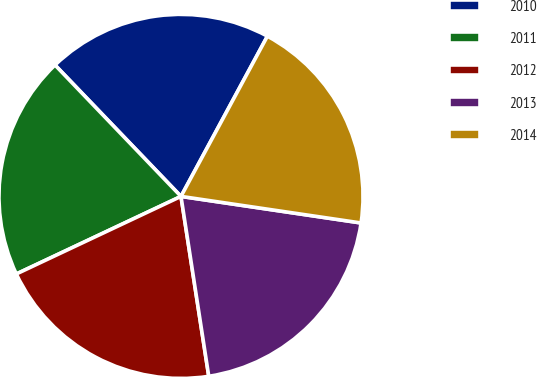<chart> <loc_0><loc_0><loc_500><loc_500><pie_chart><fcel>2010<fcel>2011<fcel>2012<fcel>2013<fcel>2014<nl><fcel>20.04%<fcel>19.84%<fcel>20.43%<fcel>20.23%<fcel>19.46%<nl></chart> 